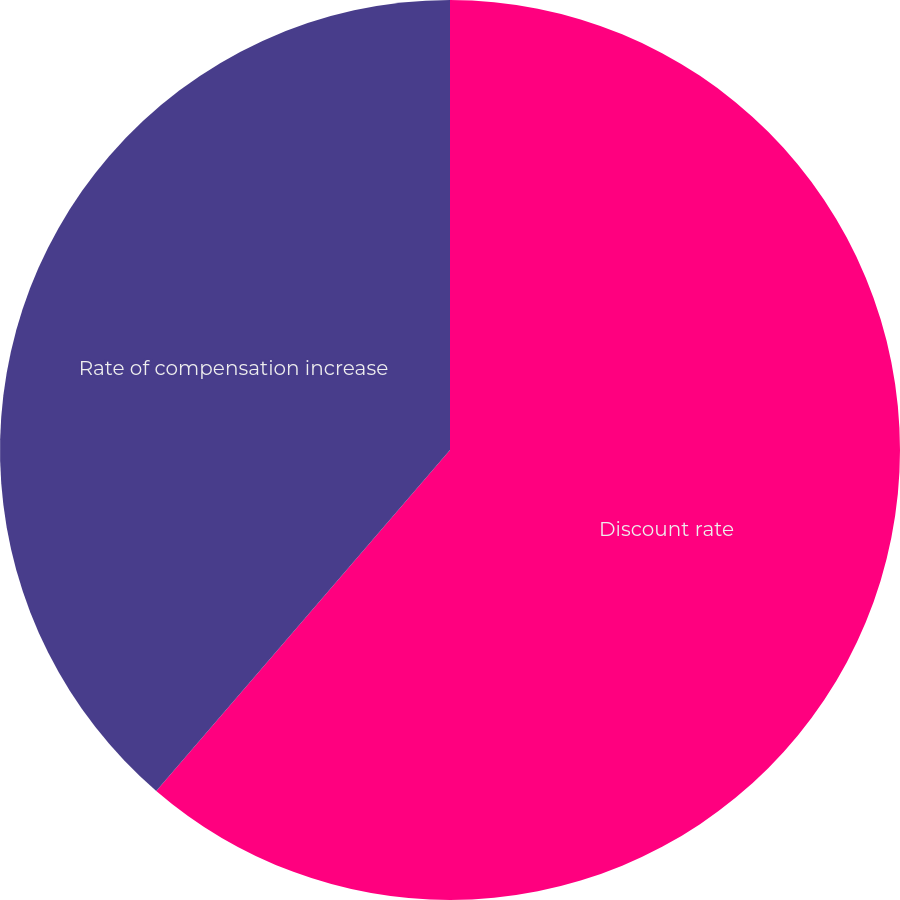Convert chart. <chart><loc_0><loc_0><loc_500><loc_500><pie_chart><fcel>Discount rate<fcel>Rate of compensation increase<nl><fcel>61.32%<fcel>38.68%<nl></chart> 